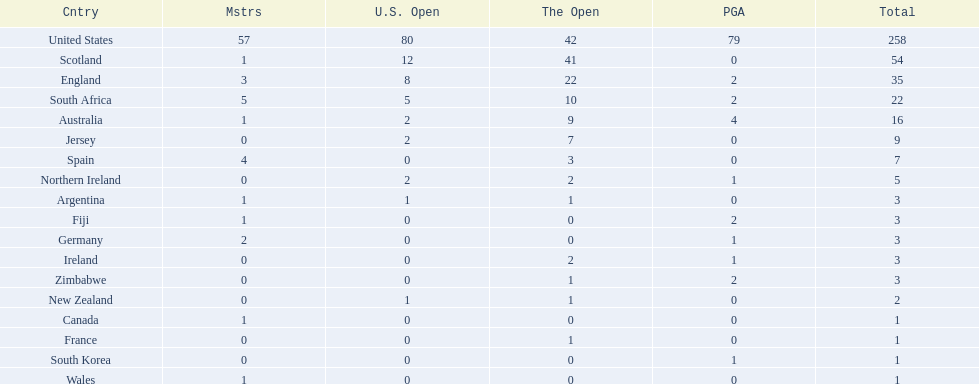What is the count of countries that have yielded the same amount of championship golf players as canada? 3. 